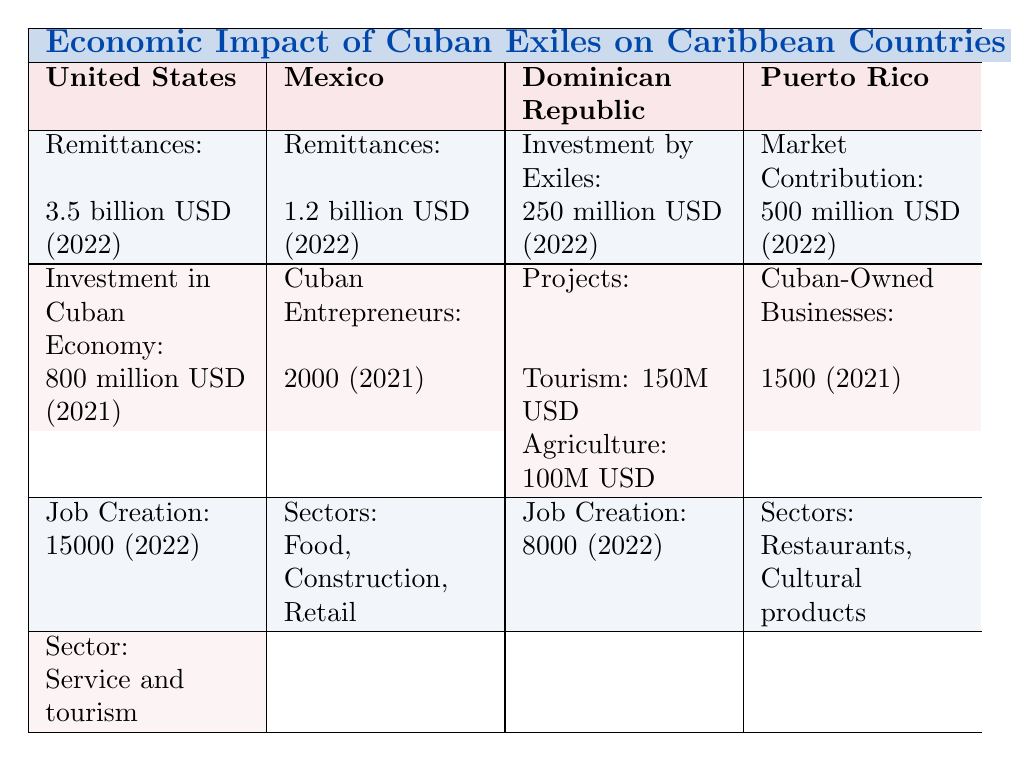What is the value of remittances from Cuban exiles in the United States? The table shows that remittances from Cuban exiles in the United States amounted to 3.5 billion USD in 2022.
Answer: 3.5 billion USD How many jobs were created by Cuban exiles in the Dominican Republic? According to the table, Cuban exiles created 8,000 jobs in the Dominican Republic in 2022.
Answer: 8,000 What is the total investment by Cuban exiles in the Dominican Republic in 2022? The total investment by Cuban exiles in the Dominican Republic is 250 million USD according to the table.
Answer: 250 million USD Is the value of Cuban-owned businesses in Puerto Rico more than 1 billion USD? The table lists the value of Cuban-owned businesses in Puerto Rico as 500 million USD, which is less than 1 billion USD.
Answer: No How many sectors do Cuban entrepreneurs in Mexico operate in? The table indicates that Cuban entrepreneurs in Mexico operate in 3 sectors: Food, Construction, and Retail.
Answer: 3 sectors What is the combined value of remittances from Cuban exiles in the United States and Mexico for 2022? The remittances are 3.5 billion USD from the United States and 1.2 billion USD from Mexico. Combining these values gives 3.5 billion + 1.2 billion = 4.7 billion USD.
Answer: 4.7 billion USD Which country had the highest job creation due to Cuban exiles, and what was the count? According to the table, the United States had the highest job creation with a count of 15,000 in 2022, compared to 8,000 in the Dominican Republic and 2,000 entrepreneurs in Mexico.
Answer: United States, 15,000 What was the value of investment in the Cuban economy by Cuban exiles in the United States in 2021? The table states that the value of investment in the Cuban economy by Cuban exiles in the United States was 800 million USD in 2021.
Answer: 800 million USD What sectors do Cuban-owned businesses in Puerto Rico focus on? The table shows that Cuban-owned businesses in Puerto Rico focus on two sectors: Restaurants and Cultural products.
Answer: Restaurants, Cultural products 